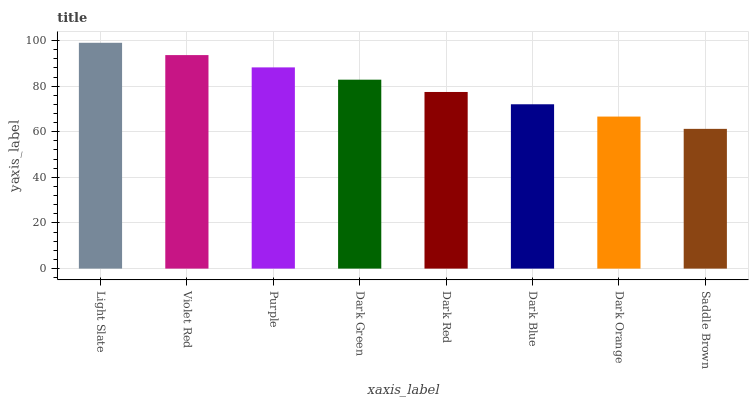Is Saddle Brown the minimum?
Answer yes or no. Yes. Is Light Slate the maximum?
Answer yes or no. Yes. Is Violet Red the minimum?
Answer yes or no. No. Is Violet Red the maximum?
Answer yes or no. No. Is Light Slate greater than Violet Red?
Answer yes or no. Yes. Is Violet Red less than Light Slate?
Answer yes or no. Yes. Is Violet Red greater than Light Slate?
Answer yes or no. No. Is Light Slate less than Violet Red?
Answer yes or no. No. Is Dark Green the high median?
Answer yes or no. Yes. Is Dark Red the low median?
Answer yes or no. Yes. Is Dark Orange the high median?
Answer yes or no. No. Is Dark Orange the low median?
Answer yes or no. No. 